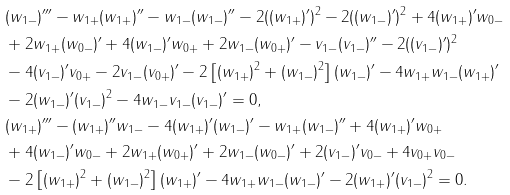<formula> <loc_0><loc_0><loc_500><loc_500>& ( w _ { 1 - } ) ^ { \prime \prime \prime } - w _ { 1 + } ( w _ { 1 + } ) ^ { \prime \prime } - w _ { 1 - } ( w _ { 1 - } ) ^ { \prime \prime } - 2 ( ( w _ { 1 + } ) ^ { \prime } ) ^ { 2 } - 2 ( ( w _ { 1 - } ) ^ { \prime } ) ^ { 2 } + 4 ( w _ { 1 + } ) ^ { \prime } w _ { 0 - } \\ & + 2 w _ { 1 + } ( w _ { 0 - } ) ^ { \prime } + 4 ( w _ { 1 - } ) ^ { \prime } w _ { 0 + } + 2 w _ { 1 - } ( w _ { 0 + } ) ^ { \prime } - v _ { 1 - } ( v _ { 1 - } ) ^ { \prime \prime } - 2 ( ( v _ { 1 - } ) ^ { \prime } ) ^ { 2 } \\ & - 4 ( v _ { 1 - } ) ^ { \prime } v _ { 0 + } - 2 v _ { 1 - } ( v _ { 0 + } ) ^ { \prime } - 2 \left [ ( w _ { 1 + } ) ^ { 2 } + ( w _ { 1 - } ) ^ { 2 } \right ] ( w _ { 1 - } ) ^ { \prime } - 4 w _ { 1 + } w _ { 1 - } ( w _ { 1 + } ) ^ { \prime } \\ & - 2 ( w _ { 1 - } ) ^ { \prime } ( v _ { 1 - } ) ^ { 2 } - 4 w _ { 1 - } v _ { 1 - } ( v _ { 1 - } ) ^ { \prime } = 0 , \\ & ( w _ { 1 + } ) ^ { \prime \prime \prime } - ( w _ { 1 + } ) ^ { \prime \prime } w _ { 1 - } - 4 ( w _ { 1 + } ) ^ { \prime } ( w _ { 1 - } ) ^ { \prime } - w _ { 1 + } ( w _ { 1 - } ) ^ { \prime \prime } + 4 ( w _ { 1 + } ) ^ { \prime } w _ { 0 + } \\ & + 4 ( w _ { 1 - } ) ^ { \prime } w _ { 0 - } + 2 w _ { 1 + } ( w _ { 0 + } ) ^ { \prime } + 2 w _ { 1 - } ( w _ { 0 - } ) ^ { \prime } + 2 ( v _ { 1 - } ) ^ { \prime } v _ { 0 - } + 4 v _ { 0 + } v _ { 0 - } \\ & - 2 \left [ ( w _ { 1 + } ) ^ { 2 } + ( w _ { 1 - } ) ^ { 2 } \right ] ( w _ { 1 + } ) ^ { \prime } - 4 w _ { 1 + } w _ { 1 - } ( w _ { 1 - } ) ^ { \prime } - 2 ( w _ { 1 + } ) ^ { \prime } ( v _ { 1 - } ) ^ { 2 } = 0 .</formula> 